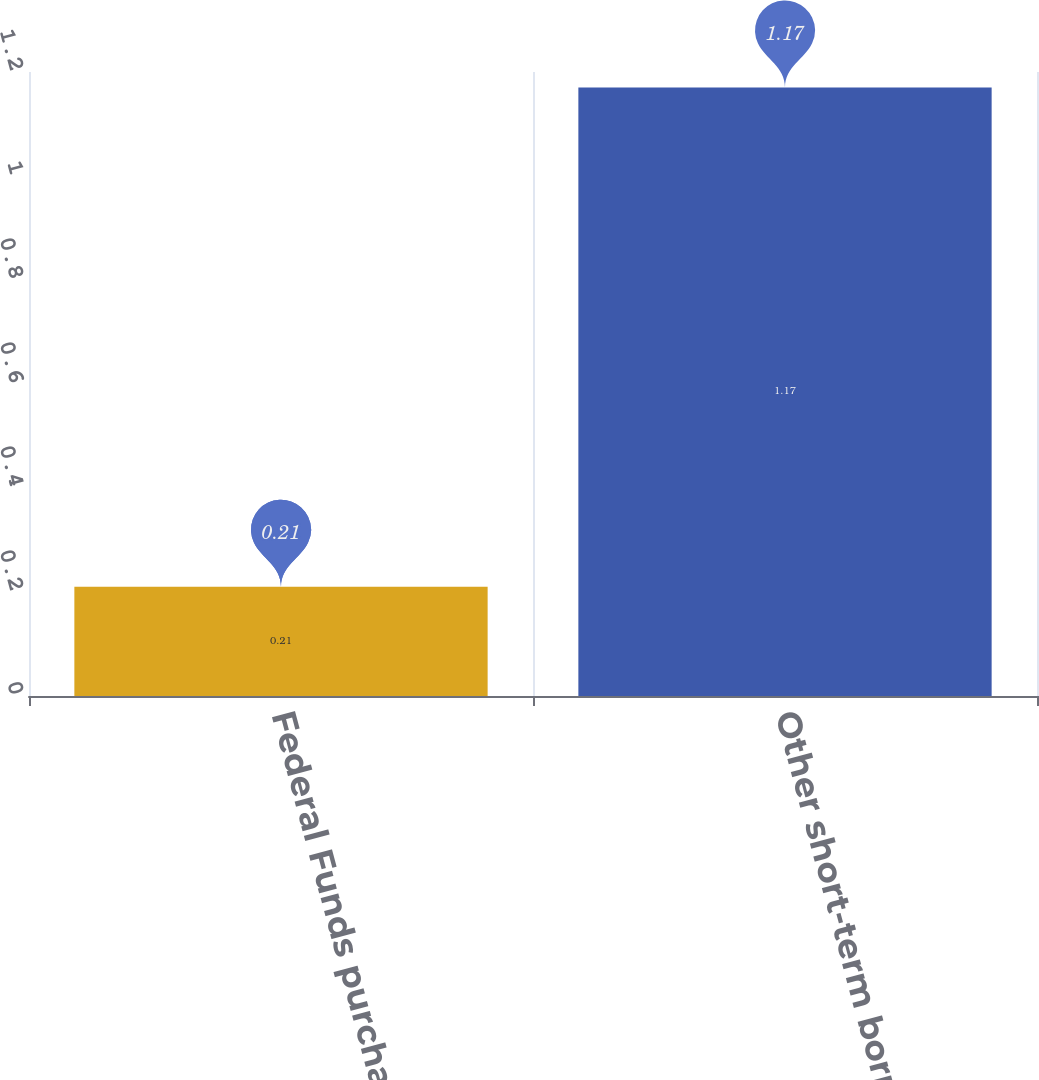Convert chart. <chart><loc_0><loc_0><loc_500><loc_500><bar_chart><fcel>Federal Funds purchased and<fcel>Other short-term borrowings<nl><fcel>0.21<fcel>1.17<nl></chart> 